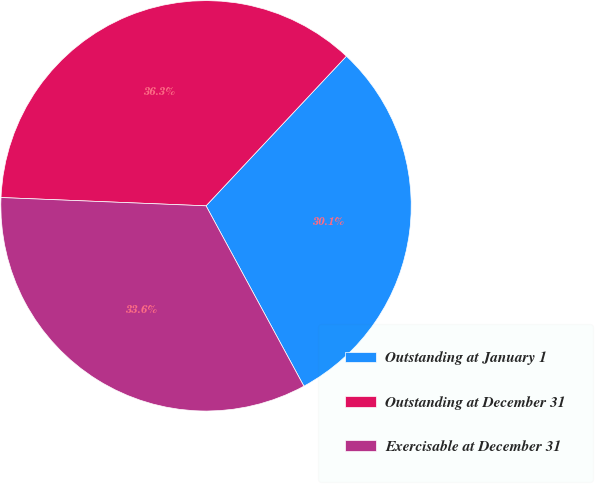<chart> <loc_0><loc_0><loc_500><loc_500><pie_chart><fcel>Outstanding at January 1<fcel>Outstanding at December 31<fcel>Exercisable at December 31<nl><fcel>30.1%<fcel>36.35%<fcel>33.56%<nl></chart> 